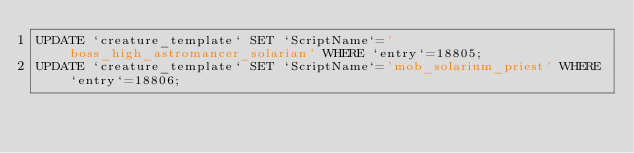Convert code to text. <code><loc_0><loc_0><loc_500><loc_500><_SQL_>UPDATE `creature_template` SET `ScriptName`='boss_high_astromancer_solarian' WHERE `entry`=18805;
UPDATE `creature_template` SET `ScriptName`='mob_solarium_priest' WHERE `entry`=18806;
</code> 